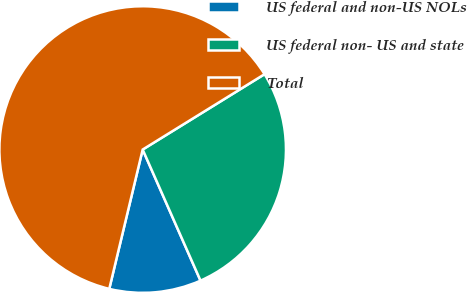Convert chart to OTSL. <chart><loc_0><loc_0><loc_500><loc_500><pie_chart><fcel>US federal and non-US NOLs<fcel>US federal non- US and state<fcel>Total<nl><fcel>10.36%<fcel>27.2%<fcel>62.44%<nl></chart> 